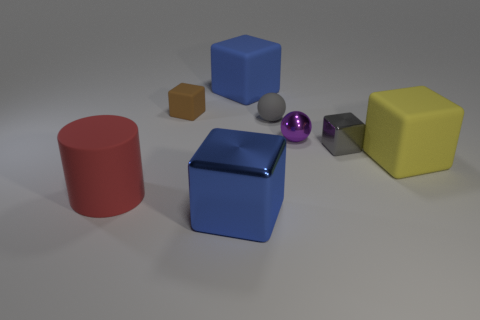How does the texture of the red cylinder compare to that of the yellow cube? The red cylinder has a smoother and more reflective surface, indicating a rubber-like material, while the yellow cube appears more matte and less reflective, suggesting a surface texture that might be akin to hard plastic. 